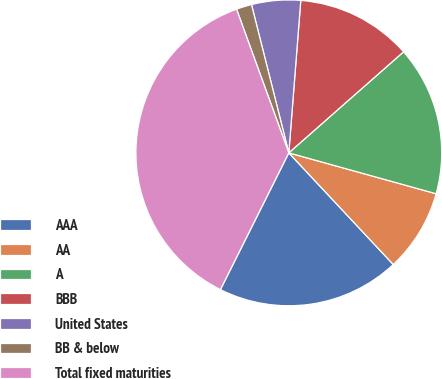Convert chart. <chart><loc_0><loc_0><loc_500><loc_500><pie_chart><fcel>AAA<fcel>AA<fcel>A<fcel>BBB<fcel>United States<fcel>BB & below<fcel>Total fixed maturities<nl><fcel>19.35%<fcel>8.72%<fcel>15.8%<fcel>12.26%<fcel>5.17%<fcel>1.63%<fcel>37.06%<nl></chart> 